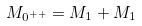Convert formula to latex. <formula><loc_0><loc_0><loc_500><loc_500>M _ { 0 ^ { + + } } = M _ { 1 } + M _ { 1 }</formula> 